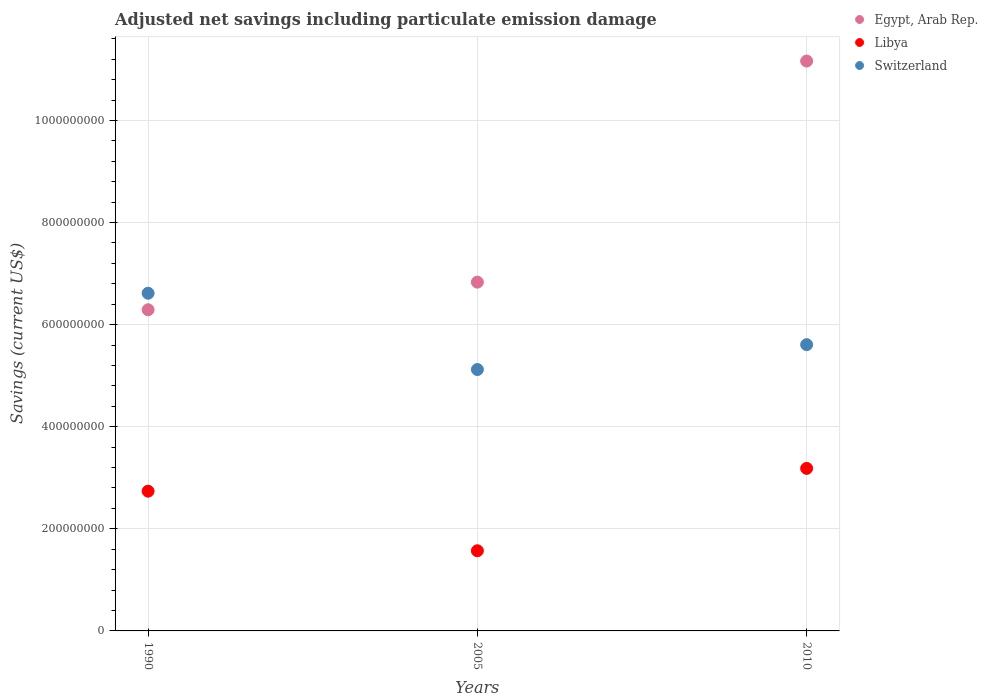How many different coloured dotlines are there?
Offer a very short reply. 3. What is the net savings in Egypt, Arab Rep. in 2010?
Give a very brief answer. 1.12e+09. Across all years, what is the maximum net savings in Egypt, Arab Rep.?
Offer a very short reply. 1.12e+09. Across all years, what is the minimum net savings in Libya?
Your answer should be compact. 1.57e+08. In which year was the net savings in Egypt, Arab Rep. maximum?
Provide a succinct answer. 2010. What is the total net savings in Switzerland in the graph?
Your response must be concise. 1.73e+09. What is the difference between the net savings in Egypt, Arab Rep. in 1990 and that in 2005?
Make the answer very short. -5.41e+07. What is the difference between the net savings in Libya in 2005 and the net savings in Egypt, Arab Rep. in 2010?
Give a very brief answer. -9.59e+08. What is the average net savings in Switzerland per year?
Your answer should be very brief. 5.78e+08. In the year 2010, what is the difference between the net savings in Libya and net savings in Egypt, Arab Rep.?
Provide a short and direct response. -7.98e+08. In how many years, is the net savings in Egypt, Arab Rep. greater than 680000000 US$?
Give a very brief answer. 2. What is the ratio of the net savings in Libya in 1990 to that in 2005?
Your response must be concise. 1.74. What is the difference between the highest and the second highest net savings in Egypt, Arab Rep.?
Provide a succinct answer. 4.33e+08. What is the difference between the highest and the lowest net savings in Egypt, Arab Rep.?
Give a very brief answer. 4.87e+08. Is the sum of the net savings in Egypt, Arab Rep. in 1990 and 2010 greater than the maximum net savings in Libya across all years?
Make the answer very short. Yes. Does the net savings in Switzerland monotonically increase over the years?
Give a very brief answer. No. Is the net savings in Switzerland strictly less than the net savings in Libya over the years?
Your answer should be compact. No. How many dotlines are there?
Offer a very short reply. 3. How many years are there in the graph?
Offer a very short reply. 3. What is the difference between two consecutive major ticks on the Y-axis?
Keep it short and to the point. 2.00e+08. Where does the legend appear in the graph?
Ensure brevity in your answer.  Top right. How many legend labels are there?
Ensure brevity in your answer.  3. How are the legend labels stacked?
Your response must be concise. Vertical. What is the title of the graph?
Ensure brevity in your answer.  Adjusted net savings including particulate emission damage. What is the label or title of the Y-axis?
Your answer should be very brief. Savings (current US$). What is the Savings (current US$) of Egypt, Arab Rep. in 1990?
Your answer should be compact. 6.29e+08. What is the Savings (current US$) in Libya in 1990?
Offer a terse response. 2.74e+08. What is the Savings (current US$) in Switzerland in 1990?
Keep it short and to the point. 6.61e+08. What is the Savings (current US$) in Egypt, Arab Rep. in 2005?
Your answer should be very brief. 6.83e+08. What is the Savings (current US$) in Libya in 2005?
Give a very brief answer. 1.57e+08. What is the Savings (current US$) in Switzerland in 2005?
Provide a succinct answer. 5.12e+08. What is the Savings (current US$) of Egypt, Arab Rep. in 2010?
Ensure brevity in your answer.  1.12e+09. What is the Savings (current US$) of Libya in 2010?
Ensure brevity in your answer.  3.18e+08. What is the Savings (current US$) in Switzerland in 2010?
Your answer should be very brief. 5.61e+08. Across all years, what is the maximum Savings (current US$) in Egypt, Arab Rep.?
Offer a very short reply. 1.12e+09. Across all years, what is the maximum Savings (current US$) of Libya?
Offer a terse response. 3.18e+08. Across all years, what is the maximum Savings (current US$) of Switzerland?
Your answer should be very brief. 6.61e+08. Across all years, what is the minimum Savings (current US$) in Egypt, Arab Rep.?
Provide a succinct answer. 6.29e+08. Across all years, what is the minimum Savings (current US$) in Libya?
Offer a very short reply. 1.57e+08. Across all years, what is the minimum Savings (current US$) in Switzerland?
Your response must be concise. 5.12e+08. What is the total Savings (current US$) in Egypt, Arab Rep. in the graph?
Give a very brief answer. 2.43e+09. What is the total Savings (current US$) in Libya in the graph?
Ensure brevity in your answer.  7.49e+08. What is the total Savings (current US$) in Switzerland in the graph?
Your response must be concise. 1.73e+09. What is the difference between the Savings (current US$) of Egypt, Arab Rep. in 1990 and that in 2005?
Your answer should be compact. -5.41e+07. What is the difference between the Savings (current US$) in Libya in 1990 and that in 2005?
Make the answer very short. 1.17e+08. What is the difference between the Savings (current US$) of Switzerland in 1990 and that in 2005?
Your response must be concise. 1.49e+08. What is the difference between the Savings (current US$) of Egypt, Arab Rep. in 1990 and that in 2010?
Offer a terse response. -4.87e+08. What is the difference between the Savings (current US$) of Libya in 1990 and that in 2010?
Offer a very short reply. -4.47e+07. What is the difference between the Savings (current US$) in Switzerland in 1990 and that in 2010?
Keep it short and to the point. 1.01e+08. What is the difference between the Savings (current US$) of Egypt, Arab Rep. in 2005 and that in 2010?
Your response must be concise. -4.33e+08. What is the difference between the Savings (current US$) of Libya in 2005 and that in 2010?
Offer a terse response. -1.61e+08. What is the difference between the Savings (current US$) in Switzerland in 2005 and that in 2010?
Provide a short and direct response. -4.87e+07. What is the difference between the Savings (current US$) in Egypt, Arab Rep. in 1990 and the Savings (current US$) in Libya in 2005?
Offer a terse response. 4.72e+08. What is the difference between the Savings (current US$) of Egypt, Arab Rep. in 1990 and the Savings (current US$) of Switzerland in 2005?
Provide a short and direct response. 1.17e+08. What is the difference between the Savings (current US$) of Libya in 1990 and the Savings (current US$) of Switzerland in 2005?
Keep it short and to the point. -2.38e+08. What is the difference between the Savings (current US$) of Egypt, Arab Rep. in 1990 and the Savings (current US$) of Libya in 2010?
Your answer should be compact. 3.11e+08. What is the difference between the Savings (current US$) in Egypt, Arab Rep. in 1990 and the Savings (current US$) in Switzerland in 2010?
Provide a short and direct response. 6.84e+07. What is the difference between the Savings (current US$) in Libya in 1990 and the Savings (current US$) in Switzerland in 2010?
Provide a short and direct response. -2.87e+08. What is the difference between the Savings (current US$) in Egypt, Arab Rep. in 2005 and the Savings (current US$) in Libya in 2010?
Your answer should be very brief. 3.65e+08. What is the difference between the Savings (current US$) of Egypt, Arab Rep. in 2005 and the Savings (current US$) of Switzerland in 2010?
Provide a succinct answer. 1.22e+08. What is the difference between the Savings (current US$) of Libya in 2005 and the Savings (current US$) of Switzerland in 2010?
Your answer should be very brief. -4.04e+08. What is the average Savings (current US$) in Egypt, Arab Rep. per year?
Provide a succinct answer. 8.10e+08. What is the average Savings (current US$) in Libya per year?
Offer a terse response. 2.50e+08. What is the average Savings (current US$) of Switzerland per year?
Make the answer very short. 5.78e+08. In the year 1990, what is the difference between the Savings (current US$) in Egypt, Arab Rep. and Savings (current US$) in Libya?
Your answer should be very brief. 3.55e+08. In the year 1990, what is the difference between the Savings (current US$) of Egypt, Arab Rep. and Savings (current US$) of Switzerland?
Your answer should be very brief. -3.23e+07. In the year 1990, what is the difference between the Savings (current US$) of Libya and Savings (current US$) of Switzerland?
Provide a short and direct response. -3.88e+08. In the year 2005, what is the difference between the Savings (current US$) of Egypt, Arab Rep. and Savings (current US$) of Libya?
Offer a very short reply. 5.26e+08. In the year 2005, what is the difference between the Savings (current US$) of Egypt, Arab Rep. and Savings (current US$) of Switzerland?
Make the answer very short. 1.71e+08. In the year 2005, what is the difference between the Savings (current US$) in Libya and Savings (current US$) in Switzerland?
Your answer should be compact. -3.55e+08. In the year 2010, what is the difference between the Savings (current US$) in Egypt, Arab Rep. and Savings (current US$) in Libya?
Provide a succinct answer. 7.98e+08. In the year 2010, what is the difference between the Savings (current US$) in Egypt, Arab Rep. and Savings (current US$) in Switzerland?
Your response must be concise. 5.56e+08. In the year 2010, what is the difference between the Savings (current US$) in Libya and Savings (current US$) in Switzerland?
Give a very brief answer. -2.42e+08. What is the ratio of the Savings (current US$) in Egypt, Arab Rep. in 1990 to that in 2005?
Give a very brief answer. 0.92. What is the ratio of the Savings (current US$) of Libya in 1990 to that in 2005?
Your answer should be compact. 1.74. What is the ratio of the Savings (current US$) in Switzerland in 1990 to that in 2005?
Give a very brief answer. 1.29. What is the ratio of the Savings (current US$) of Egypt, Arab Rep. in 1990 to that in 2010?
Your answer should be compact. 0.56. What is the ratio of the Savings (current US$) of Libya in 1990 to that in 2010?
Provide a short and direct response. 0.86. What is the ratio of the Savings (current US$) of Switzerland in 1990 to that in 2010?
Your answer should be very brief. 1.18. What is the ratio of the Savings (current US$) in Egypt, Arab Rep. in 2005 to that in 2010?
Ensure brevity in your answer.  0.61. What is the ratio of the Savings (current US$) of Libya in 2005 to that in 2010?
Your answer should be very brief. 0.49. What is the ratio of the Savings (current US$) of Switzerland in 2005 to that in 2010?
Provide a succinct answer. 0.91. What is the difference between the highest and the second highest Savings (current US$) of Egypt, Arab Rep.?
Give a very brief answer. 4.33e+08. What is the difference between the highest and the second highest Savings (current US$) in Libya?
Provide a succinct answer. 4.47e+07. What is the difference between the highest and the second highest Savings (current US$) in Switzerland?
Your answer should be very brief. 1.01e+08. What is the difference between the highest and the lowest Savings (current US$) in Egypt, Arab Rep.?
Give a very brief answer. 4.87e+08. What is the difference between the highest and the lowest Savings (current US$) in Libya?
Your response must be concise. 1.61e+08. What is the difference between the highest and the lowest Savings (current US$) of Switzerland?
Ensure brevity in your answer.  1.49e+08. 